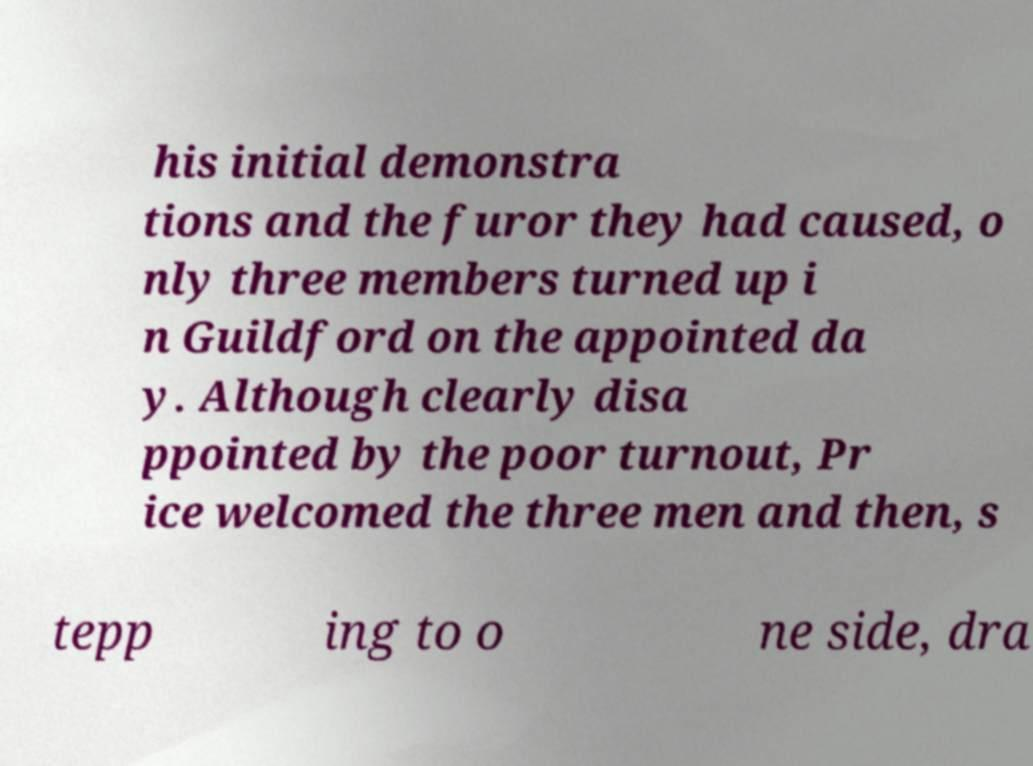Please identify and transcribe the text found in this image. his initial demonstra tions and the furor they had caused, o nly three members turned up i n Guildford on the appointed da y. Although clearly disa ppointed by the poor turnout, Pr ice welcomed the three men and then, s tepp ing to o ne side, dra 